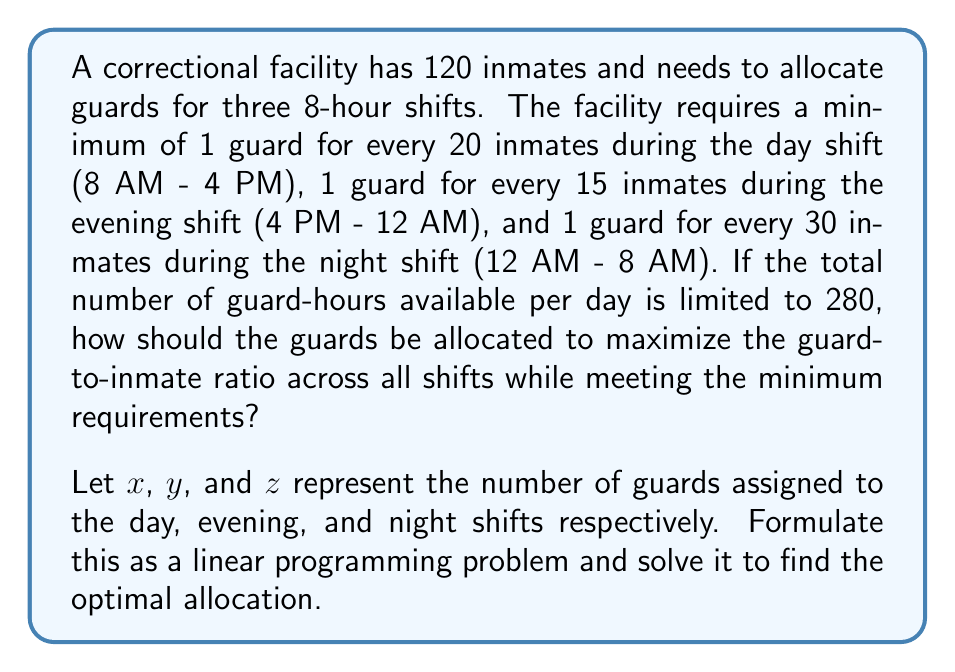Teach me how to tackle this problem. To solve this problem, we need to set up a linear programming model and then solve it. Let's break it down step-by-step:

1. Define the variables:
   $x$ = number of guards on day shift
   $y$ = number of guards on evening shift
   $z$ = number of guards on night shift

2. Objective function:
   We want to maximize the guard-to-inmate ratio across all shifts. This can be represented as:
   
   Maximize: $\frac{x}{120} + \frac{y}{120} + \frac{z}{120}$ or simply $x + y + z$

3. Constraints:
   a) Minimum requirements for each shift:
      Day shift: $x \geq \frac{120}{20} = 6$
      Evening shift: $y \geq \frac{120}{15} = 8$
      Night shift: $z \geq \frac{120}{30} = 4$

   b) Total guard-hours constraint:
      $8x + 8y + 8z \leq 280$

   c) Non-negativity constraints:
      $x, y, z \geq 0$

4. The linear programming problem:

   Maximize: $x + y + z$
   Subject to:
   $x \geq 6$
   $y \geq 8$
   $z \geq 4$
   $8x + 8y + 8z \leq 280$
   $x, y, z \geq 0$

5. Solving the linear programming problem:
   We can solve this using the simplex method or a linear programming solver. The optimal solution is:

   $x = 6$
   $y = 19$
   $z = 10$

6. Verification:
   - Day shift: 6 guards (meets minimum requirement)
   - Evening shift: 19 guards (exceeds minimum requirement)
   - Night shift: 10 guards (exceeds minimum requirement)
   - Total guard-hours: $8(6) + 8(19) + 8(10) = 280$ (meets the limit)

This allocation maximizes the guard-to-inmate ratio while meeting all constraints.
Answer: The optimal allocation of guards is:
Day shift (8 AM - 4 PM): 6 guards
Evening shift (4 PM - 12 AM): 19 guards
Night shift (12 AM - 8 AM): 10 guards 